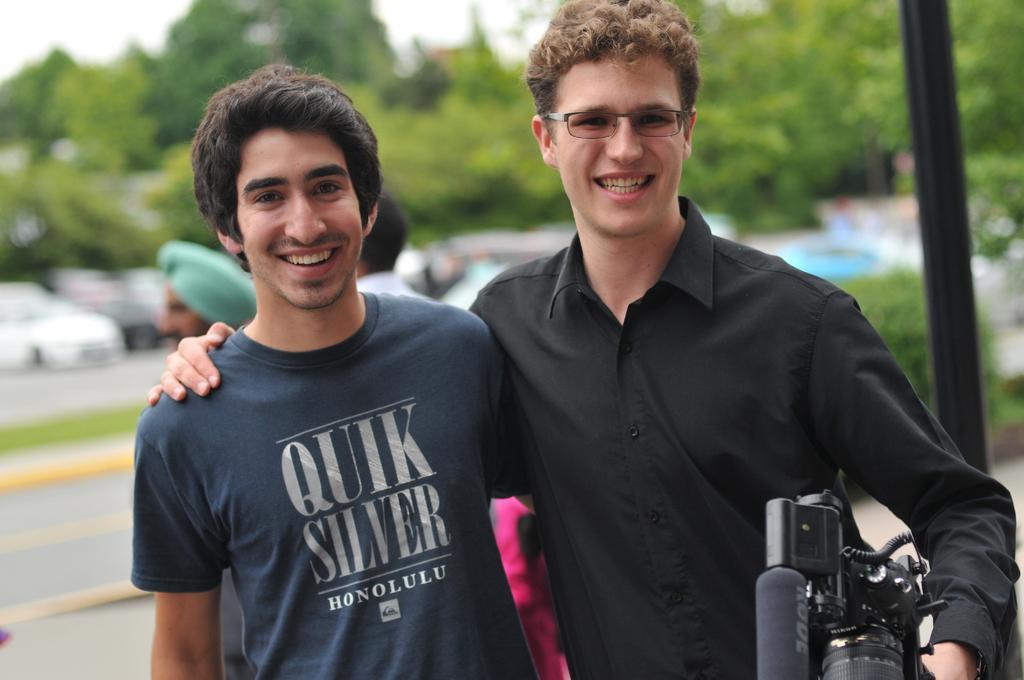Describe this image in one or two sentences. In this picture there are two people those who are standing at the center of the image, the person who is standing at the right side of the image, he is holding the camera in his hand, there are some trees around the area of the image and cars, it seems to be a road side view. 